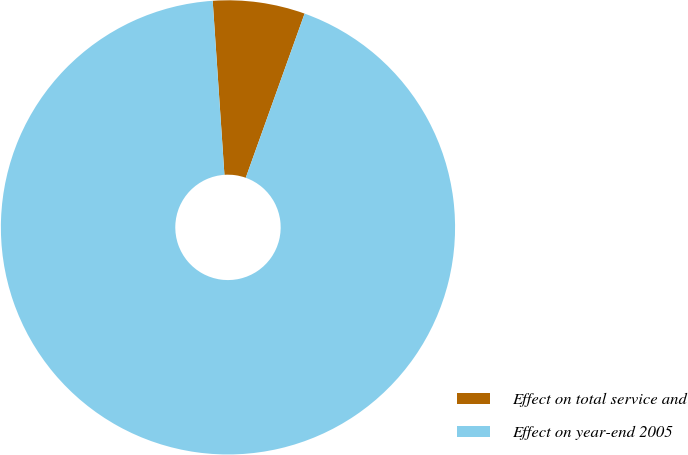<chart> <loc_0><loc_0><loc_500><loc_500><pie_chart><fcel>Effect on total service and<fcel>Effect on year-end 2005<nl><fcel>6.55%<fcel>93.45%<nl></chart> 